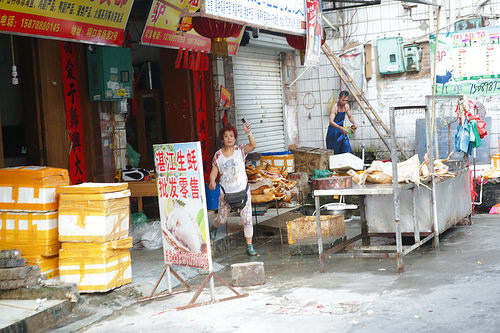<image>
Is there a women next to the sign? Yes. The women is positioned adjacent to the sign, located nearby in the same general area. 